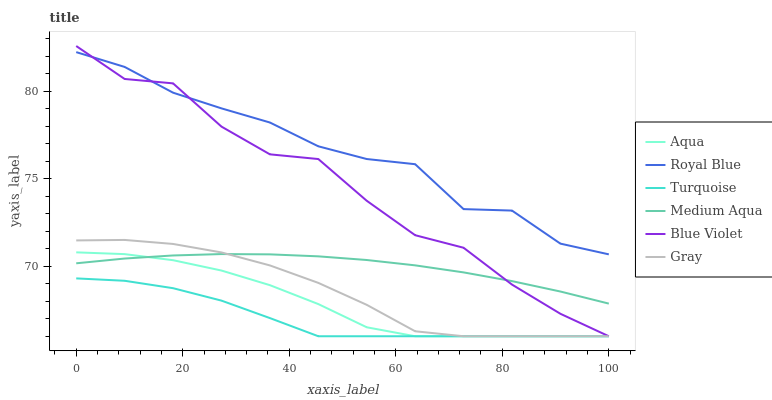Does Turquoise have the minimum area under the curve?
Answer yes or no. Yes. Does Royal Blue have the maximum area under the curve?
Answer yes or no. Yes. Does Aqua have the minimum area under the curve?
Answer yes or no. No. Does Aqua have the maximum area under the curve?
Answer yes or no. No. Is Medium Aqua the smoothest?
Answer yes or no. Yes. Is Blue Violet the roughest?
Answer yes or no. Yes. Is Turquoise the smoothest?
Answer yes or no. No. Is Turquoise the roughest?
Answer yes or no. No. Does Gray have the lowest value?
Answer yes or no. Yes. Does Royal Blue have the lowest value?
Answer yes or no. No. Does Blue Violet have the highest value?
Answer yes or no. Yes. Does Aqua have the highest value?
Answer yes or no. No. Is Medium Aqua less than Royal Blue?
Answer yes or no. Yes. Is Royal Blue greater than Gray?
Answer yes or no. Yes. Does Aqua intersect Blue Violet?
Answer yes or no. Yes. Is Aqua less than Blue Violet?
Answer yes or no. No. Is Aqua greater than Blue Violet?
Answer yes or no. No. Does Medium Aqua intersect Royal Blue?
Answer yes or no. No. 